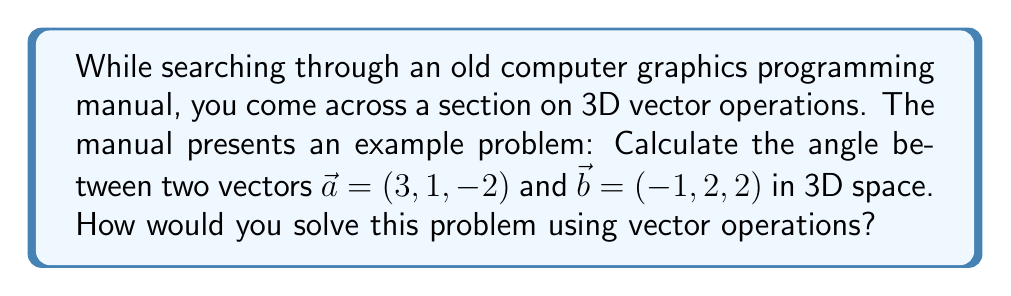What is the answer to this math problem? To calculate the angle between two vectors in 3D space, we can use the dot product formula:

$$\cos \theta = \frac{\vec{a} \cdot \vec{b}}{|\vec{a}| |\vec{b}|}$$

Where $\theta$ is the angle between the vectors, $\vec{a} \cdot \vec{b}$ is the dot product of the vectors, and $|\vec{a}|$ and $|\vec{b}|$ are the magnitudes of the vectors.

Step 1: Calculate the dot product $\vec{a} \cdot \vec{b}$
$$\vec{a} \cdot \vec{b} = (3)(-1) + (1)(2) + (-2)(2) = -3 + 2 - 4 = -5$$

Step 2: Calculate the magnitudes of the vectors
$$|\vec{a}| = \sqrt{3^2 + 1^2 + (-2)^2} = \sqrt{9 + 1 + 4} = \sqrt{14}$$
$$|\vec{b}| = \sqrt{(-1)^2 + 2^2 + 2^2} = \sqrt{1 + 4 + 4} = 3$$

Step 3: Substitute the values into the formula
$$\cos \theta = \frac{-5}{\sqrt{14} \cdot 3}$$

Step 4: Solve for $\theta$ using the inverse cosine function
$$\theta = \arccos\left(\frac{-5}{\sqrt{14} \cdot 3}\right)$$

Step 5: Calculate the final result (in radians)
$$\theta \approx 2.0344 \text{ radians}$$

To convert to degrees, multiply by $\frac{180}{\pi}$:
$$\theta \approx 2.0344 \cdot \frac{180}{\pi} \approx 116.57°$$
Answer: The angle between the vectors $\vec{a} = (3, 1, -2)$ and $\vec{b} = (-1, 2, 2)$ is approximately 2.0344 radians or 116.57 degrees. 